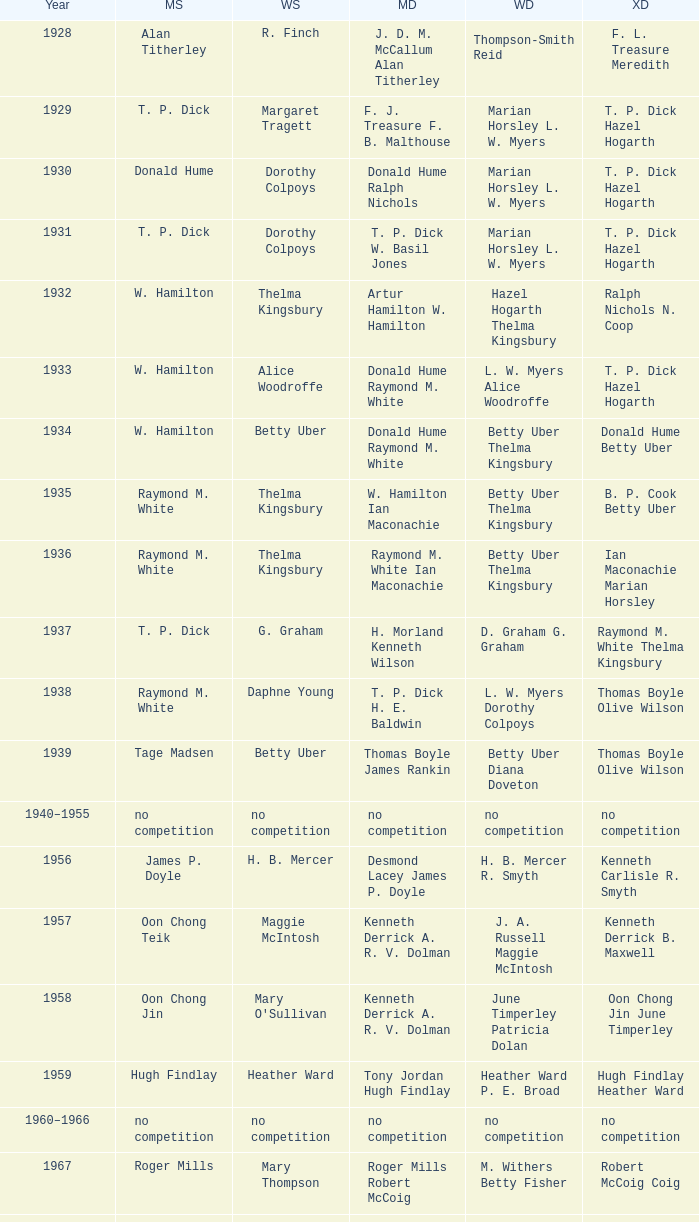When ian maconachie and marian horsley claimed victory in the mixed doubles, who secured the men's singles title? Raymond M. White. 